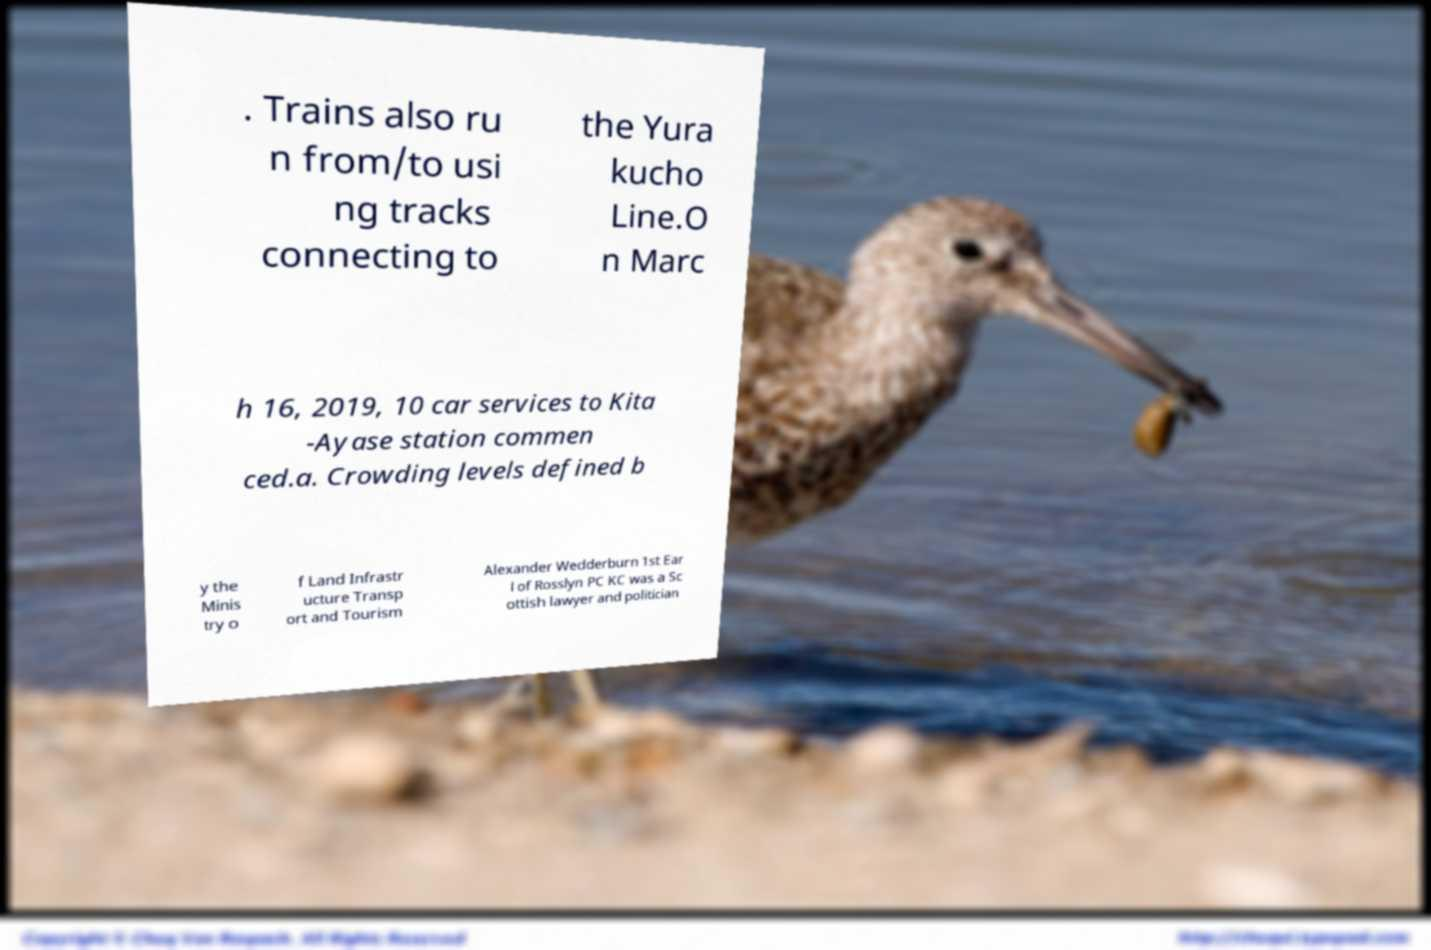For documentation purposes, I need the text within this image transcribed. Could you provide that? . Trains also ru n from/to usi ng tracks connecting to the Yura kucho Line.O n Marc h 16, 2019, 10 car services to Kita -Ayase station commen ced.a. Crowding levels defined b y the Minis try o f Land Infrastr ucture Transp ort and Tourism Alexander Wedderburn 1st Ear l of Rosslyn PC KC was a Sc ottish lawyer and politician 